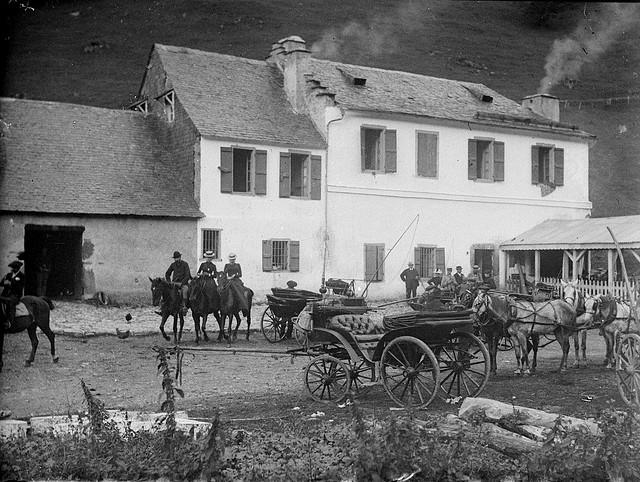What animals are shown?
Give a very brief answer. Horses. What color is the picture?
Quick response, please. Black and white. Is the picture from modern times?
Give a very brief answer. No. Has this field been recently mowed?
Write a very short answer. No. What are the people sitting on?
Be succinct. Horses. Is this a factory?
Keep it brief. No. 